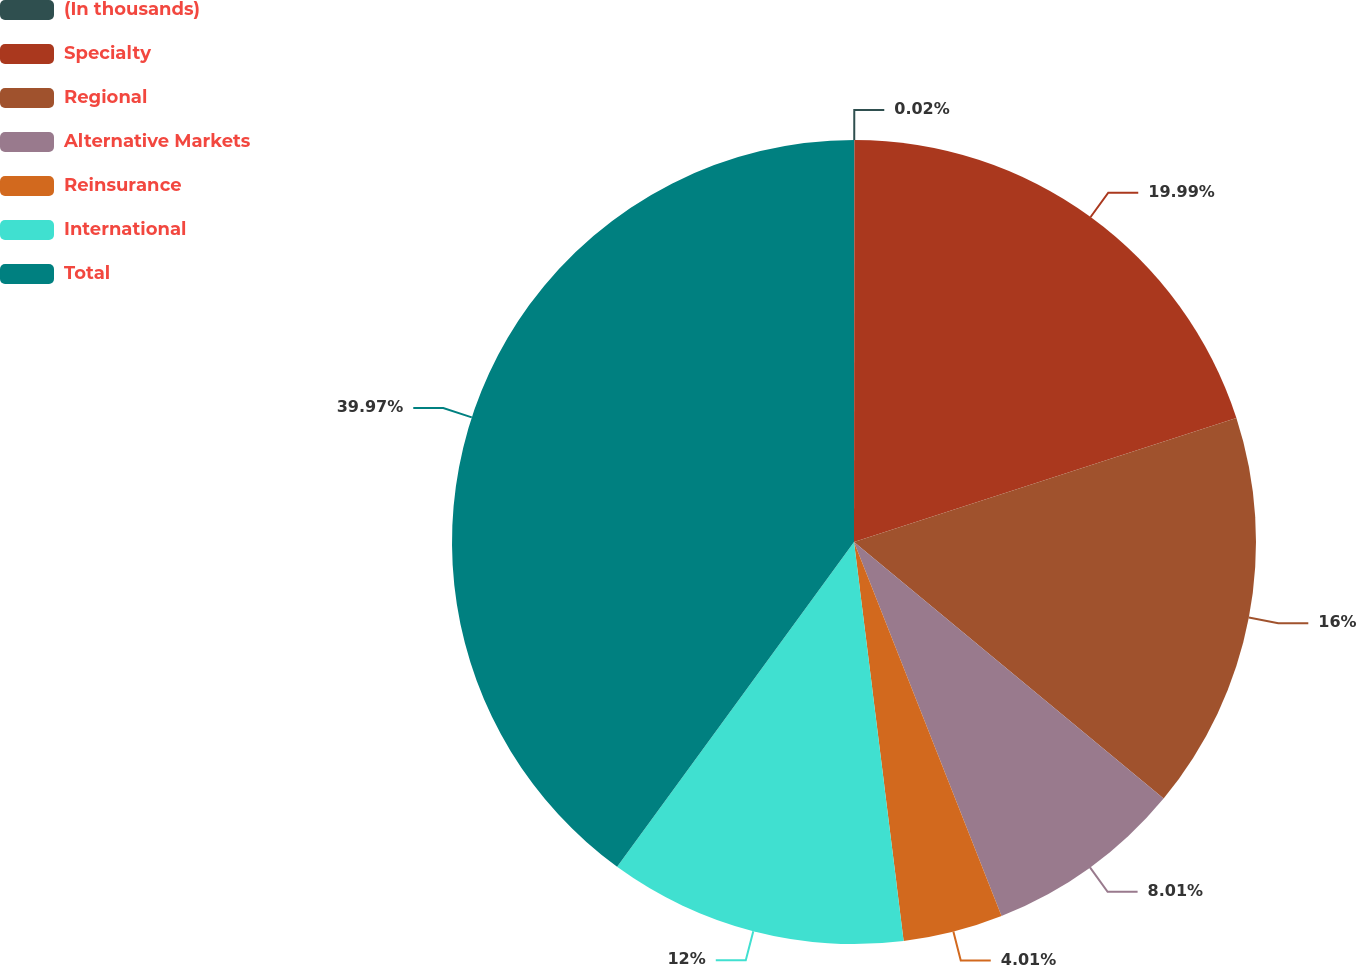Convert chart to OTSL. <chart><loc_0><loc_0><loc_500><loc_500><pie_chart><fcel>(In thousands)<fcel>Specialty<fcel>Regional<fcel>Alternative Markets<fcel>Reinsurance<fcel>International<fcel>Total<nl><fcel>0.02%<fcel>19.99%<fcel>16.0%<fcel>8.01%<fcel>4.01%<fcel>12.0%<fcel>39.97%<nl></chart> 